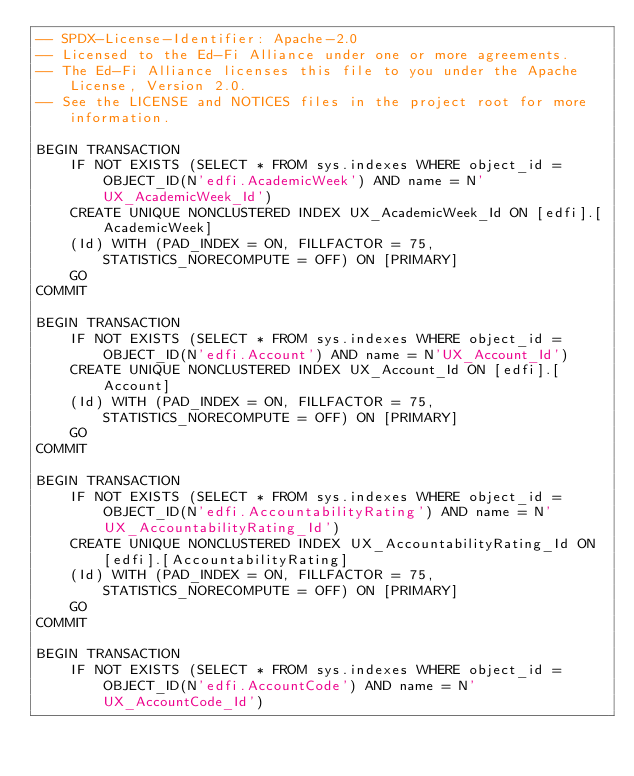Convert code to text. <code><loc_0><loc_0><loc_500><loc_500><_SQL_>-- SPDX-License-Identifier: Apache-2.0
-- Licensed to the Ed-Fi Alliance under one or more agreements.
-- The Ed-Fi Alliance licenses this file to you under the Apache License, Version 2.0.
-- See the LICENSE and NOTICES files in the project root for more information.

BEGIN TRANSACTION
    IF NOT EXISTS (SELECT * FROM sys.indexes WHERE object_id = OBJECT_ID(N'edfi.AcademicWeek') AND name = N'UX_AcademicWeek_Id')
    CREATE UNIQUE NONCLUSTERED INDEX UX_AcademicWeek_Id ON [edfi].[AcademicWeek]
    (Id) WITH (PAD_INDEX = ON, FILLFACTOR = 75, STATISTICS_NORECOMPUTE = OFF) ON [PRIMARY]
    GO
COMMIT

BEGIN TRANSACTION
    IF NOT EXISTS (SELECT * FROM sys.indexes WHERE object_id = OBJECT_ID(N'edfi.Account') AND name = N'UX_Account_Id')
    CREATE UNIQUE NONCLUSTERED INDEX UX_Account_Id ON [edfi].[Account]
    (Id) WITH (PAD_INDEX = ON, FILLFACTOR = 75, STATISTICS_NORECOMPUTE = OFF) ON [PRIMARY]
    GO
COMMIT

BEGIN TRANSACTION
    IF NOT EXISTS (SELECT * FROM sys.indexes WHERE object_id = OBJECT_ID(N'edfi.AccountabilityRating') AND name = N'UX_AccountabilityRating_Id')
    CREATE UNIQUE NONCLUSTERED INDEX UX_AccountabilityRating_Id ON [edfi].[AccountabilityRating]
    (Id) WITH (PAD_INDEX = ON, FILLFACTOR = 75, STATISTICS_NORECOMPUTE = OFF) ON [PRIMARY]
    GO
COMMIT

BEGIN TRANSACTION
    IF NOT EXISTS (SELECT * FROM sys.indexes WHERE object_id = OBJECT_ID(N'edfi.AccountCode') AND name = N'UX_AccountCode_Id')</code> 